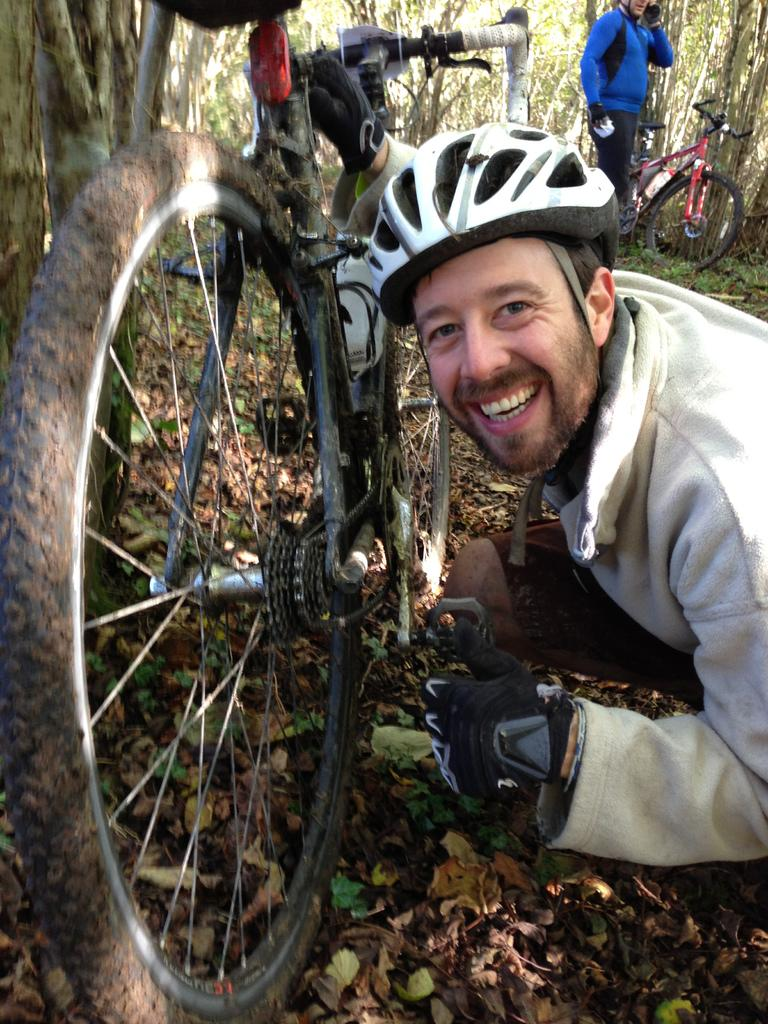How many people are in the image? There are two men in the image. What are the men wearing on their heads? Both men are wearing helmets. What else are the men wearing? Both men are wearing gloves. Can you describe the facial expression of one of the men? One of the men is smiling. What type of vehicle can be seen in the image? There are bicycles in the image. What can be seen in the background of the image? There are trees in the background of the image. How many cats are sitting on the bicycles in the image? There are no cats present in the image; it features two men wearing helmets and gloves, bicycles, and trees in the background. What type of plantation can be seen in the image? There is no plantation visible in the image. 